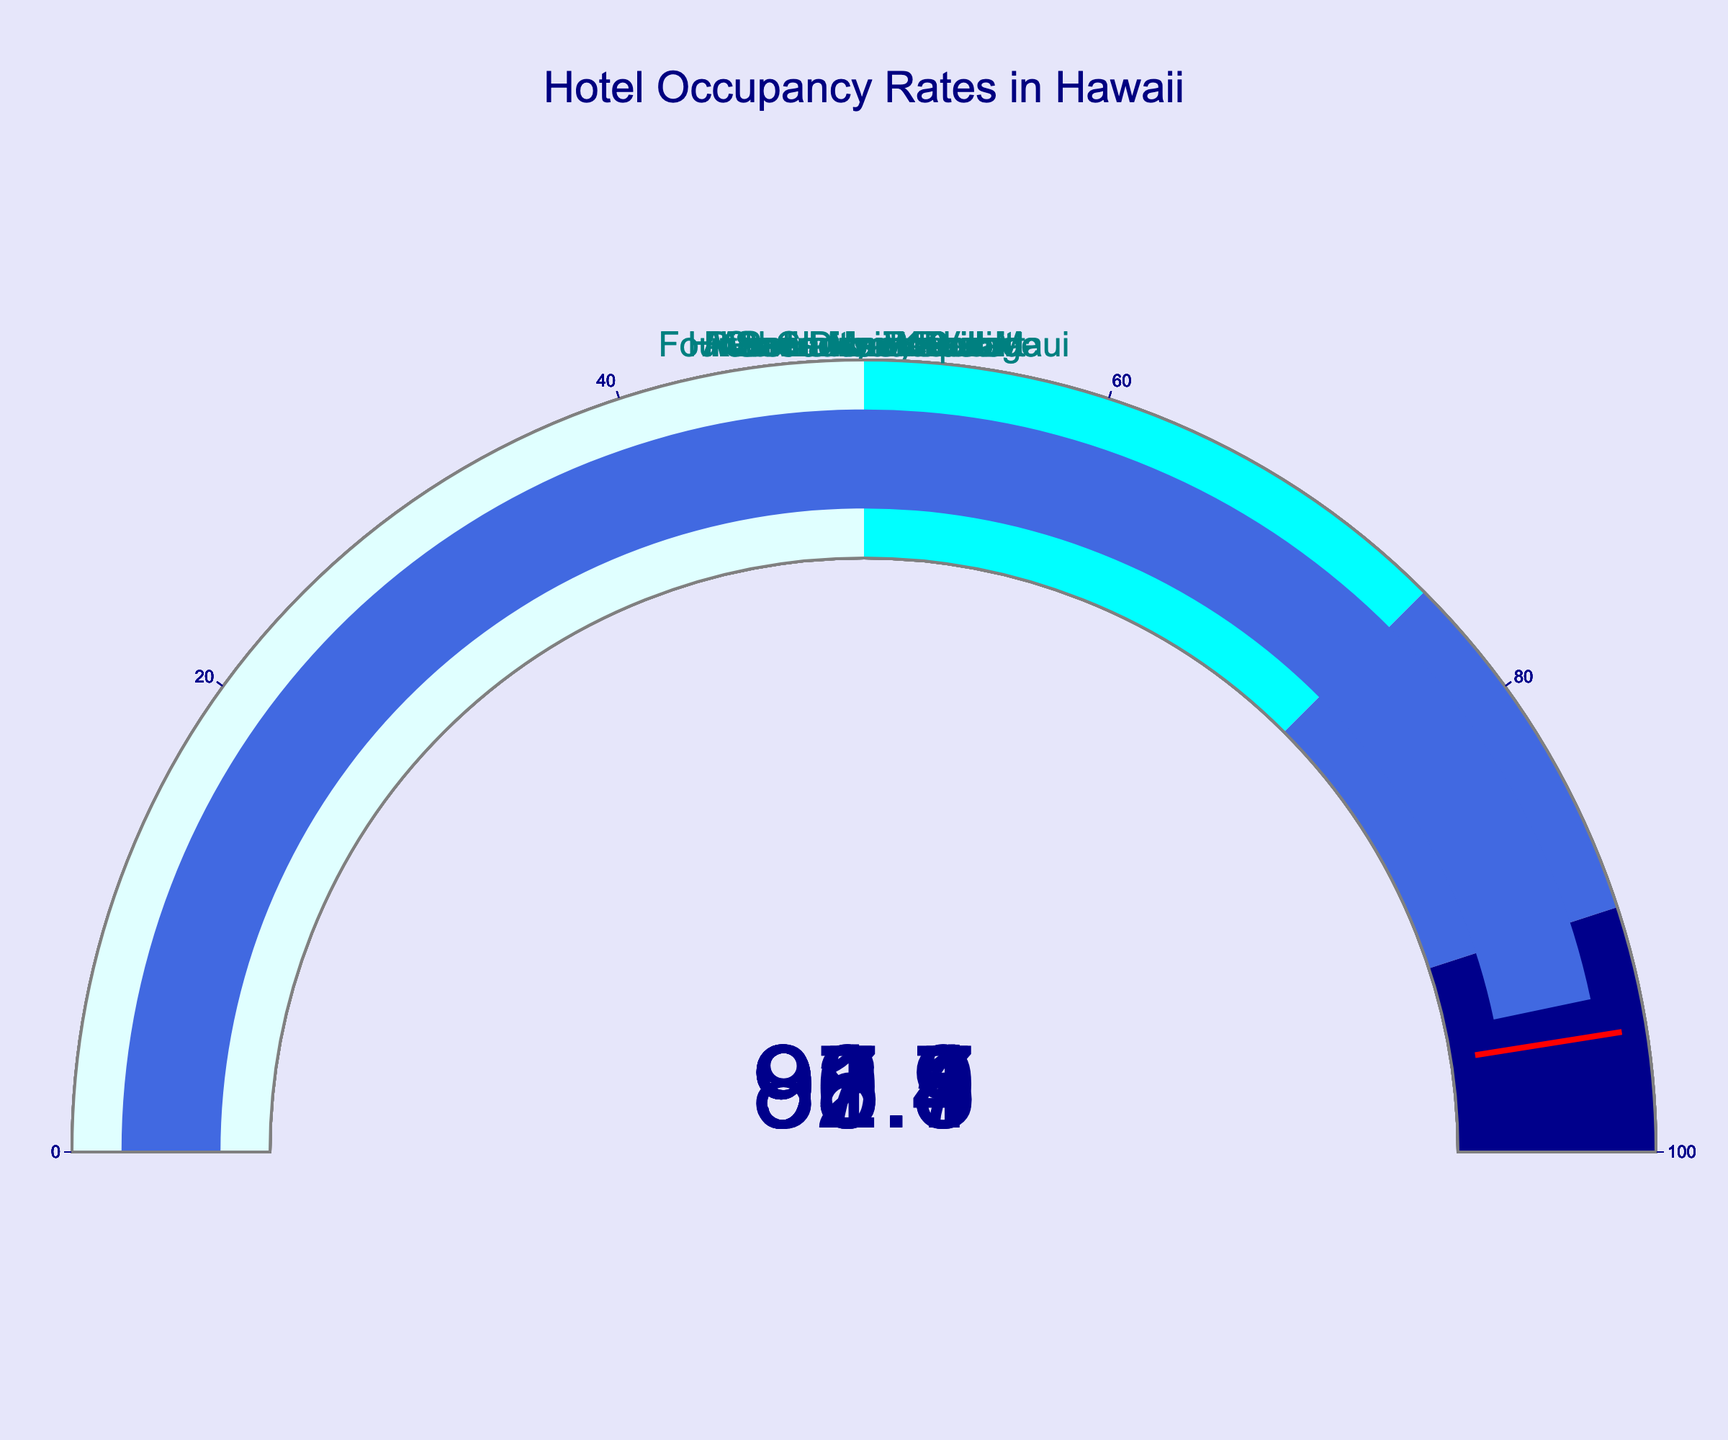Which hotel has the highest occupancy rate? The Four Seasons Resort Maui has an occupancy rate of 95.3%, which is the highest among the listed hotels.
Answer: Four Seasons Resort Maui What's the average occupancy rate of all the hotels? To find the average, sum up the occupancy rates and divide by the number of hotels: (92.5 + 88.7 + 95.3 + 90.1 + 87.9 + 91.8 + 93.4) / 7 = 91.1%
Answer: 91.1% Which hotel has the lowest occupancy rate during the peak season? The Sheraton Waikiki has an occupancy rate of 87.9%, which is the lowest among the hotels in the list.
Answer: Sheraton Waikiki What is the range of occupancy rates among the hotels? The range is calculated by subtracting the lowest rate from the highest: 95.3% - 87.9% = 7.4%
Answer: 7.4% How many hotels have an occupancy rate above 90%? The hotels with occupancy rates above 90% are Hilton Hawaiian Village, Four Seasons Resort Maui, Grand Hyatt Kauai, Westin Maui Resort, and Ritz-Carlton Kapalua, totaling 5 hotels.
Answer: 5 What's the difference in occupancy rate between Hilton Hawaiian Village and Aulani Disney Resort? Subtract the occupancy rate of Aulani Disney Resort from that of Hilton Hawaiian Village: 92.5% - 88.7% = 3.8%
Answer: 3.8% Which hotel's gauge shows a reading closest to 90%? The Grand Hyatt Kauai has an occupancy rate of 90.1%, which is the closest to 90% among the listed hotels.
Answer: Grand Hyatt Kauai Are there more hotels with an occupancy rate below or above 90%? There are 5 hotels above 90% (Hilton Hawaiian Village, Four Seasons Resort Maui, Grand Hyatt Kauai, Westin Maui Resort, Ritz-Carlton Kapalua) and 2 below 90% (Aulani Disney Resort, Sheraton Waikiki). So, more hotels have an occupancy rate above 90%.
Answer: Above Which hotel has an occupancy rate closest to the average rate? The average rate is 91.1%, and the Westin Maui Resort has an occupancy rate closest to this value with 91.8%.
Answer: Westin Maui Resort 